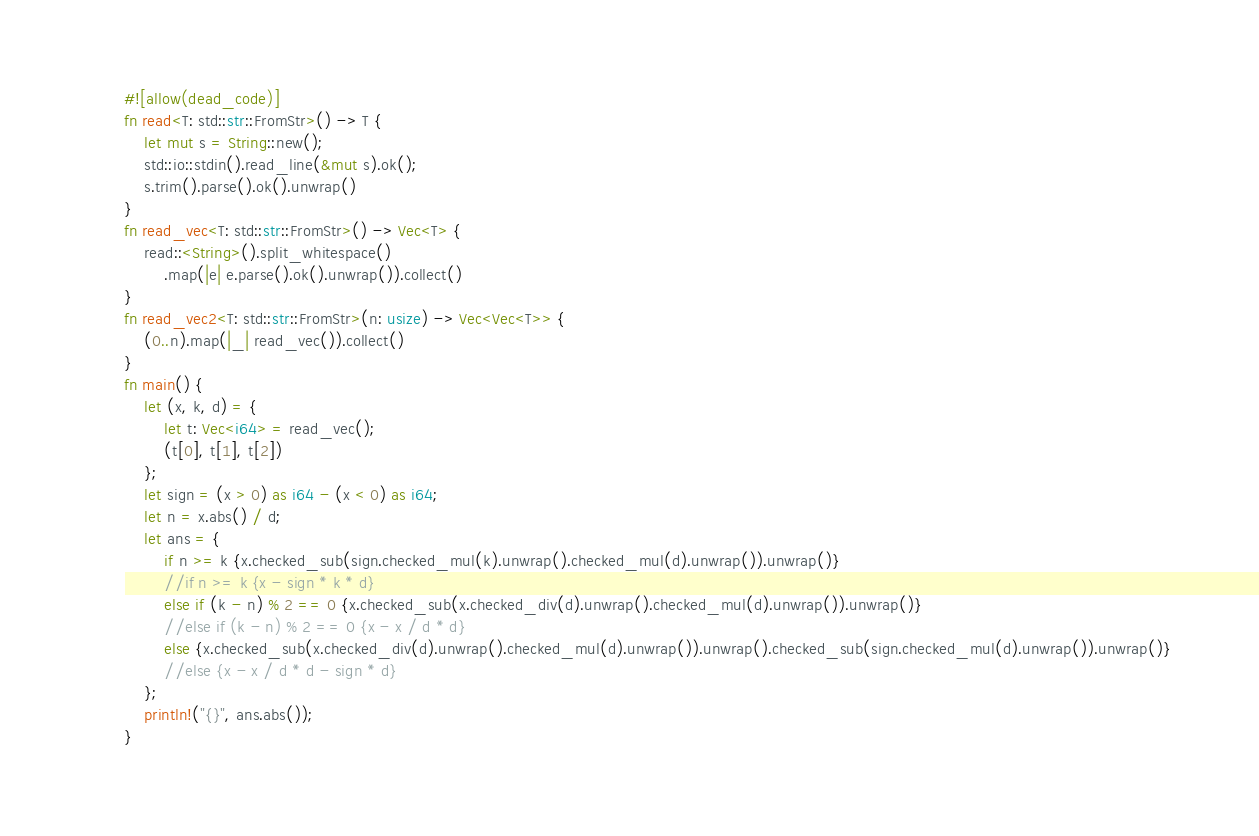Convert code to text. <code><loc_0><loc_0><loc_500><loc_500><_Rust_>#![allow(dead_code)]
fn read<T: std::str::FromStr>() -> T {
    let mut s = String::new();
    std::io::stdin().read_line(&mut s).ok();
    s.trim().parse().ok().unwrap()
}
fn read_vec<T: std::str::FromStr>() -> Vec<T> {
    read::<String>().split_whitespace()
        .map(|e| e.parse().ok().unwrap()).collect()
}
fn read_vec2<T: std::str::FromStr>(n: usize) -> Vec<Vec<T>> {
    (0..n).map(|_| read_vec()).collect()
}
fn main() {
    let (x, k, d) = {
        let t: Vec<i64> = read_vec();
        (t[0], t[1], t[2])
    };
    let sign = (x > 0) as i64 - (x < 0) as i64;
    let n = x.abs() / d;
    let ans = {
        if n >= k {x.checked_sub(sign.checked_mul(k).unwrap().checked_mul(d).unwrap()).unwrap()}
        //if n >= k {x - sign * k * d}
        else if (k - n) % 2 == 0 {x.checked_sub(x.checked_div(d).unwrap().checked_mul(d).unwrap()).unwrap()}
        //else if (k - n) % 2 == 0 {x - x / d * d}
        else {x.checked_sub(x.checked_div(d).unwrap().checked_mul(d).unwrap()).unwrap().checked_sub(sign.checked_mul(d).unwrap()).unwrap()}
        //else {x - x / d * d - sign * d}
    };
    println!("{}", ans.abs());
}</code> 